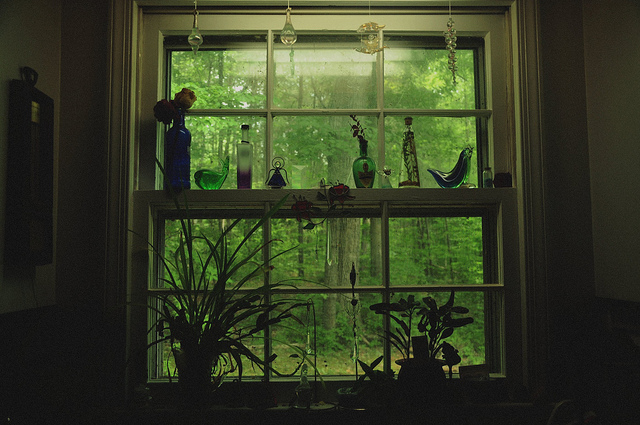Given the lush plant life visible both inside and outside, create a short scenario in which this window is a central part of a nature conservatory. In a dedicated wing of a sprawling nature conservatory, this window serves as a vital connection between the meticulously arranged indoor plant displays and the wild, untamed beauty of the forest outside. Daily, botanists and nature enthusiasts gather by this window, using its expansive view to draw inspiration for their conservation efforts. The plants arranged near the window include rare species nurtured back to health, their vibrant green leaves echoing the robust foliage outside. As a ray of sunlight filters through the window, it illuminates the glass vases, casting colorful reflections reminiscent of the diversity of life that the conservatory aims to protect. Can you summarize this idea in a single sentence? This window, bridging the cultivated plants indoors and the wild forest outside, serves as a symbol of ongoing conservation efforts in a nature conservatory. 